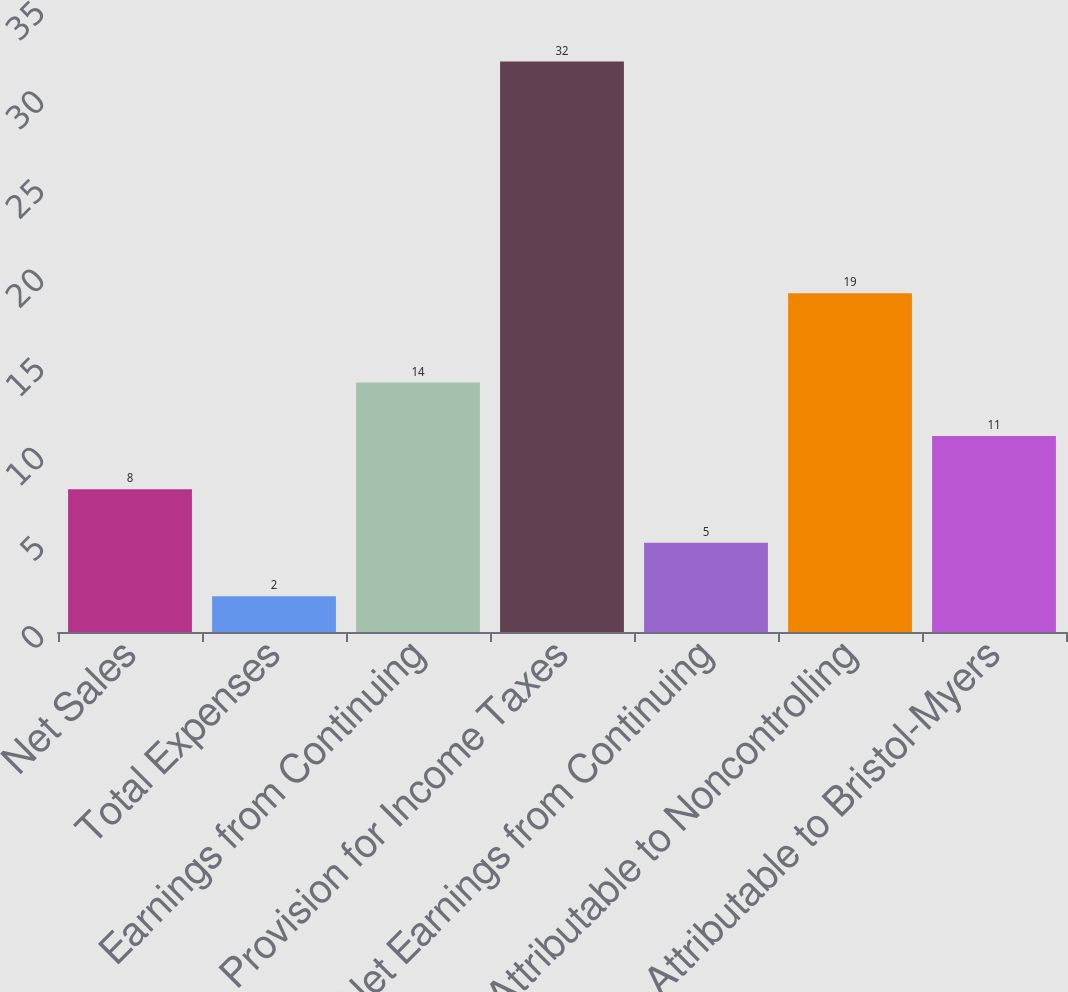Convert chart to OTSL. <chart><loc_0><loc_0><loc_500><loc_500><bar_chart><fcel>Net Sales<fcel>Total Expenses<fcel>Earnings from Continuing<fcel>Provision for Income Taxes<fcel>Net Earnings from Continuing<fcel>Attributable to Noncontrolling<fcel>Attributable to Bristol-Myers<nl><fcel>8<fcel>2<fcel>14<fcel>32<fcel>5<fcel>19<fcel>11<nl></chart> 